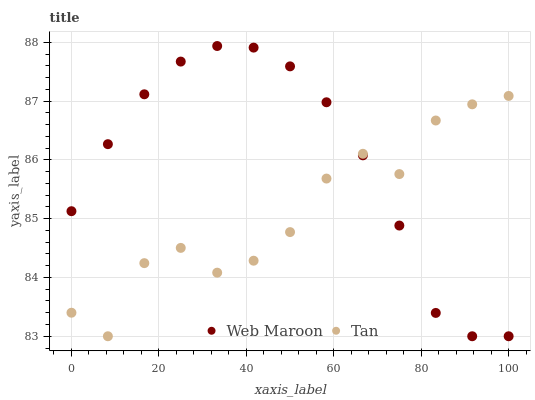Does Tan have the minimum area under the curve?
Answer yes or no. Yes. Does Web Maroon have the maximum area under the curve?
Answer yes or no. Yes. Does Web Maroon have the minimum area under the curve?
Answer yes or no. No. Is Web Maroon the smoothest?
Answer yes or no. Yes. Is Tan the roughest?
Answer yes or no. Yes. Is Web Maroon the roughest?
Answer yes or no. No. Does Tan have the lowest value?
Answer yes or no. Yes. Does Web Maroon have the highest value?
Answer yes or no. Yes. Does Web Maroon intersect Tan?
Answer yes or no. Yes. Is Web Maroon less than Tan?
Answer yes or no. No. Is Web Maroon greater than Tan?
Answer yes or no. No. 